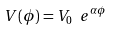Convert formula to latex. <formula><loc_0><loc_0><loc_500><loc_500>V ( \phi ) = { V _ { 0 } } \ { e ^ { \alpha \phi } }</formula> 